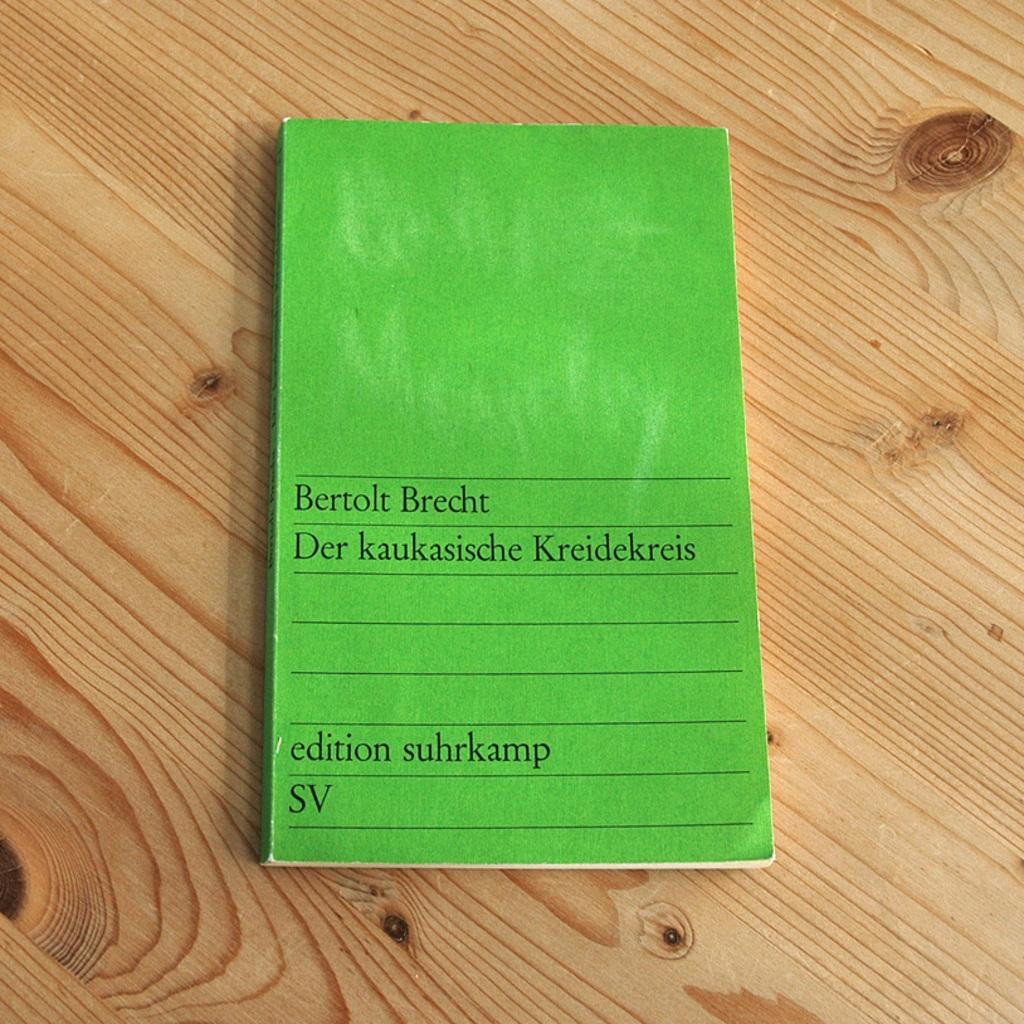<image>
Provide a brief description of the given image. A Bertolt Brecht book, "Der kaukasische Kreidekreis", on a brown wood table. 